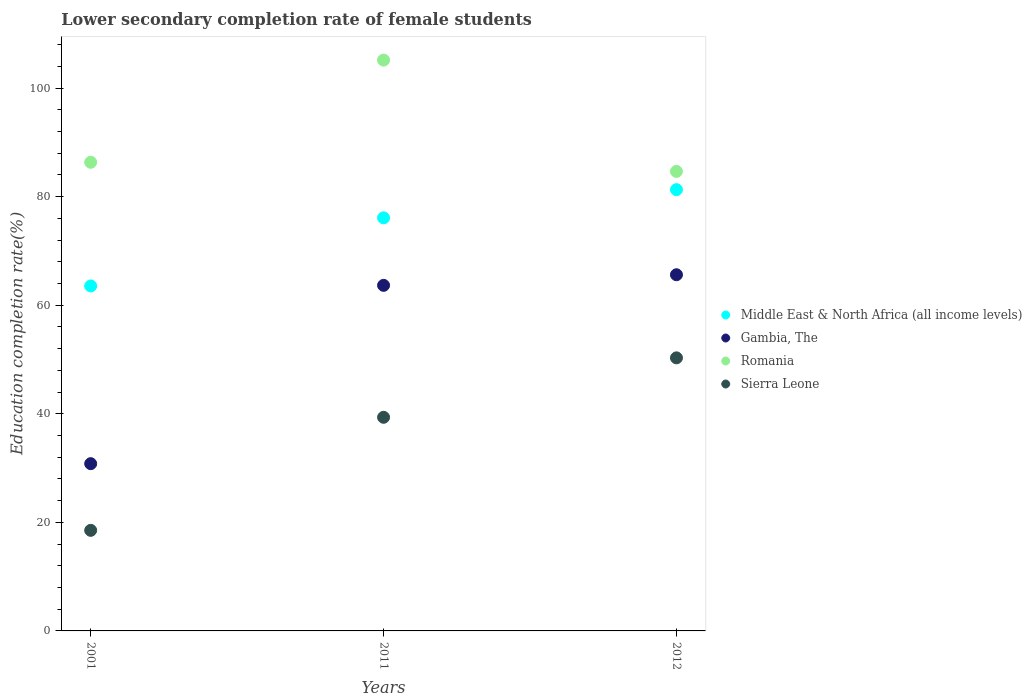Is the number of dotlines equal to the number of legend labels?
Ensure brevity in your answer.  Yes. What is the lower secondary completion rate of female students in Romania in 2012?
Provide a short and direct response. 84.65. Across all years, what is the maximum lower secondary completion rate of female students in Romania?
Give a very brief answer. 105.16. Across all years, what is the minimum lower secondary completion rate of female students in Romania?
Give a very brief answer. 84.65. In which year was the lower secondary completion rate of female students in Romania minimum?
Provide a short and direct response. 2012. What is the total lower secondary completion rate of female students in Romania in the graph?
Your answer should be compact. 276.15. What is the difference between the lower secondary completion rate of female students in Middle East & North Africa (all income levels) in 2011 and that in 2012?
Provide a short and direct response. -5.19. What is the difference between the lower secondary completion rate of female students in Middle East & North Africa (all income levels) in 2001 and the lower secondary completion rate of female students in Sierra Leone in 2012?
Keep it short and to the point. 13.24. What is the average lower secondary completion rate of female students in Romania per year?
Offer a terse response. 92.05. In the year 2012, what is the difference between the lower secondary completion rate of female students in Romania and lower secondary completion rate of female students in Middle East & North Africa (all income levels)?
Provide a succinct answer. 3.37. What is the ratio of the lower secondary completion rate of female students in Middle East & North Africa (all income levels) in 2001 to that in 2011?
Offer a very short reply. 0.84. Is the lower secondary completion rate of female students in Romania in 2001 less than that in 2012?
Make the answer very short. No. Is the difference between the lower secondary completion rate of female students in Romania in 2001 and 2011 greater than the difference between the lower secondary completion rate of female students in Middle East & North Africa (all income levels) in 2001 and 2011?
Make the answer very short. No. What is the difference between the highest and the second highest lower secondary completion rate of female students in Middle East & North Africa (all income levels)?
Give a very brief answer. 5.19. What is the difference between the highest and the lowest lower secondary completion rate of female students in Romania?
Give a very brief answer. 20.51. Is the sum of the lower secondary completion rate of female students in Gambia, The in 2011 and 2012 greater than the maximum lower secondary completion rate of female students in Romania across all years?
Your response must be concise. Yes. Is it the case that in every year, the sum of the lower secondary completion rate of female students in Gambia, The and lower secondary completion rate of female students in Romania  is greater than the sum of lower secondary completion rate of female students in Sierra Leone and lower secondary completion rate of female students in Middle East & North Africa (all income levels)?
Keep it short and to the point. No. Is the lower secondary completion rate of female students in Sierra Leone strictly greater than the lower secondary completion rate of female students in Middle East & North Africa (all income levels) over the years?
Your answer should be compact. No. How many years are there in the graph?
Make the answer very short. 3. What is the difference between two consecutive major ticks on the Y-axis?
Provide a succinct answer. 20. Does the graph contain any zero values?
Provide a short and direct response. No. What is the title of the graph?
Offer a terse response. Lower secondary completion rate of female students. What is the label or title of the X-axis?
Ensure brevity in your answer.  Years. What is the label or title of the Y-axis?
Ensure brevity in your answer.  Education completion rate(%). What is the Education completion rate(%) in Middle East & North Africa (all income levels) in 2001?
Make the answer very short. 63.55. What is the Education completion rate(%) in Gambia, The in 2001?
Provide a succinct answer. 30.81. What is the Education completion rate(%) of Romania in 2001?
Your response must be concise. 86.33. What is the Education completion rate(%) in Sierra Leone in 2001?
Make the answer very short. 18.53. What is the Education completion rate(%) in Middle East & North Africa (all income levels) in 2011?
Provide a succinct answer. 76.1. What is the Education completion rate(%) in Gambia, The in 2011?
Keep it short and to the point. 63.66. What is the Education completion rate(%) of Romania in 2011?
Provide a succinct answer. 105.16. What is the Education completion rate(%) of Sierra Leone in 2011?
Offer a very short reply. 39.35. What is the Education completion rate(%) of Middle East & North Africa (all income levels) in 2012?
Your answer should be compact. 81.29. What is the Education completion rate(%) of Gambia, The in 2012?
Offer a very short reply. 65.62. What is the Education completion rate(%) in Romania in 2012?
Provide a short and direct response. 84.65. What is the Education completion rate(%) of Sierra Leone in 2012?
Offer a very short reply. 50.3. Across all years, what is the maximum Education completion rate(%) of Middle East & North Africa (all income levels)?
Your answer should be compact. 81.29. Across all years, what is the maximum Education completion rate(%) of Gambia, The?
Provide a succinct answer. 65.62. Across all years, what is the maximum Education completion rate(%) in Romania?
Offer a very short reply. 105.16. Across all years, what is the maximum Education completion rate(%) in Sierra Leone?
Your response must be concise. 50.3. Across all years, what is the minimum Education completion rate(%) in Middle East & North Africa (all income levels)?
Ensure brevity in your answer.  63.55. Across all years, what is the minimum Education completion rate(%) in Gambia, The?
Make the answer very short. 30.81. Across all years, what is the minimum Education completion rate(%) in Romania?
Offer a very short reply. 84.65. Across all years, what is the minimum Education completion rate(%) of Sierra Leone?
Make the answer very short. 18.53. What is the total Education completion rate(%) in Middle East & North Africa (all income levels) in the graph?
Your answer should be very brief. 220.94. What is the total Education completion rate(%) in Gambia, The in the graph?
Ensure brevity in your answer.  160.09. What is the total Education completion rate(%) in Romania in the graph?
Give a very brief answer. 276.15. What is the total Education completion rate(%) in Sierra Leone in the graph?
Your response must be concise. 108.19. What is the difference between the Education completion rate(%) of Middle East & North Africa (all income levels) in 2001 and that in 2011?
Ensure brevity in your answer.  -12.55. What is the difference between the Education completion rate(%) of Gambia, The in 2001 and that in 2011?
Offer a terse response. -32.85. What is the difference between the Education completion rate(%) of Romania in 2001 and that in 2011?
Offer a very short reply. -18.83. What is the difference between the Education completion rate(%) in Sierra Leone in 2001 and that in 2011?
Your response must be concise. -20.83. What is the difference between the Education completion rate(%) of Middle East & North Africa (all income levels) in 2001 and that in 2012?
Your answer should be very brief. -17.74. What is the difference between the Education completion rate(%) of Gambia, The in 2001 and that in 2012?
Your answer should be compact. -34.81. What is the difference between the Education completion rate(%) in Romania in 2001 and that in 2012?
Your response must be concise. 1.68. What is the difference between the Education completion rate(%) of Sierra Leone in 2001 and that in 2012?
Make the answer very short. -31.78. What is the difference between the Education completion rate(%) in Middle East & North Africa (all income levels) in 2011 and that in 2012?
Offer a very short reply. -5.19. What is the difference between the Education completion rate(%) in Gambia, The in 2011 and that in 2012?
Provide a succinct answer. -1.95. What is the difference between the Education completion rate(%) in Romania in 2011 and that in 2012?
Provide a short and direct response. 20.51. What is the difference between the Education completion rate(%) of Sierra Leone in 2011 and that in 2012?
Make the answer very short. -10.95. What is the difference between the Education completion rate(%) of Middle East & North Africa (all income levels) in 2001 and the Education completion rate(%) of Gambia, The in 2011?
Your answer should be compact. -0.11. What is the difference between the Education completion rate(%) in Middle East & North Africa (all income levels) in 2001 and the Education completion rate(%) in Romania in 2011?
Provide a short and direct response. -41.61. What is the difference between the Education completion rate(%) in Middle East & North Africa (all income levels) in 2001 and the Education completion rate(%) in Sierra Leone in 2011?
Provide a short and direct response. 24.19. What is the difference between the Education completion rate(%) in Gambia, The in 2001 and the Education completion rate(%) in Romania in 2011?
Provide a short and direct response. -74.35. What is the difference between the Education completion rate(%) in Gambia, The in 2001 and the Education completion rate(%) in Sierra Leone in 2011?
Provide a short and direct response. -8.54. What is the difference between the Education completion rate(%) of Romania in 2001 and the Education completion rate(%) of Sierra Leone in 2011?
Your response must be concise. 46.98. What is the difference between the Education completion rate(%) in Middle East & North Africa (all income levels) in 2001 and the Education completion rate(%) in Gambia, The in 2012?
Give a very brief answer. -2.07. What is the difference between the Education completion rate(%) in Middle East & North Africa (all income levels) in 2001 and the Education completion rate(%) in Romania in 2012?
Offer a terse response. -21.11. What is the difference between the Education completion rate(%) in Middle East & North Africa (all income levels) in 2001 and the Education completion rate(%) in Sierra Leone in 2012?
Give a very brief answer. 13.24. What is the difference between the Education completion rate(%) in Gambia, The in 2001 and the Education completion rate(%) in Romania in 2012?
Your answer should be compact. -53.84. What is the difference between the Education completion rate(%) of Gambia, The in 2001 and the Education completion rate(%) of Sierra Leone in 2012?
Give a very brief answer. -19.49. What is the difference between the Education completion rate(%) of Romania in 2001 and the Education completion rate(%) of Sierra Leone in 2012?
Provide a short and direct response. 36.03. What is the difference between the Education completion rate(%) in Middle East & North Africa (all income levels) in 2011 and the Education completion rate(%) in Gambia, The in 2012?
Give a very brief answer. 10.48. What is the difference between the Education completion rate(%) of Middle East & North Africa (all income levels) in 2011 and the Education completion rate(%) of Romania in 2012?
Offer a terse response. -8.55. What is the difference between the Education completion rate(%) in Middle East & North Africa (all income levels) in 2011 and the Education completion rate(%) in Sierra Leone in 2012?
Make the answer very short. 25.8. What is the difference between the Education completion rate(%) of Gambia, The in 2011 and the Education completion rate(%) of Romania in 2012?
Provide a succinct answer. -20.99. What is the difference between the Education completion rate(%) in Gambia, The in 2011 and the Education completion rate(%) in Sierra Leone in 2012?
Your response must be concise. 13.36. What is the difference between the Education completion rate(%) of Romania in 2011 and the Education completion rate(%) of Sierra Leone in 2012?
Offer a very short reply. 54.86. What is the average Education completion rate(%) in Middle East & North Africa (all income levels) per year?
Give a very brief answer. 73.65. What is the average Education completion rate(%) in Gambia, The per year?
Your answer should be very brief. 53.36. What is the average Education completion rate(%) of Romania per year?
Ensure brevity in your answer.  92.05. What is the average Education completion rate(%) of Sierra Leone per year?
Your answer should be compact. 36.06. In the year 2001, what is the difference between the Education completion rate(%) in Middle East & North Africa (all income levels) and Education completion rate(%) in Gambia, The?
Provide a short and direct response. 32.74. In the year 2001, what is the difference between the Education completion rate(%) of Middle East & North Africa (all income levels) and Education completion rate(%) of Romania?
Your answer should be very brief. -22.79. In the year 2001, what is the difference between the Education completion rate(%) of Middle East & North Africa (all income levels) and Education completion rate(%) of Sierra Leone?
Your answer should be compact. 45.02. In the year 2001, what is the difference between the Education completion rate(%) of Gambia, The and Education completion rate(%) of Romania?
Give a very brief answer. -55.52. In the year 2001, what is the difference between the Education completion rate(%) in Gambia, The and Education completion rate(%) in Sierra Leone?
Offer a terse response. 12.28. In the year 2001, what is the difference between the Education completion rate(%) in Romania and Education completion rate(%) in Sierra Leone?
Provide a succinct answer. 67.81. In the year 2011, what is the difference between the Education completion rate(%) in Middle East & North Africa (all income levels) and Education completion rate(%) in Gambia, The?
Keep it short and to the point. 12.44. In the year 2011, what is the difference between the Education completion rate(%) in Middle East & North Africa (all income levels) and Education completion rate(%) in Romania?
Your response must be concise. -29.06. In the year 2011, what is the difference between the Education completion rate(%) of Middle East & North Africa (all income levels) and Education completion rate(%) of Sierra Leone?
Provide a short and direct response. 36.75. In the year 2011, what is the difference between the Education completion rate(%) of Gambia, The and Education completion rate(%) of Romania?
Ensure brevity in your answer.  -41.5. In the year 2011, what is the difference between the Education completion rate(%) in Gambia, The and Education completion rate(%) in Sierra Leone?
Offer a very short reply. 24.31. In the year 2011, what is the difference between the Education completion rate(%) of Romania and Education completion rate(%) of Sierra Leone?
Your answer should be compact. 65.81. In the year 2012, what is the difference between the Education completion rate(%) in Middle East & North Africa (all income levels) and Education completion rate(%) in Gambia, The?
Make the answer very short. 15.67. In the year 2012, what is the difference between the Education completion rate(%) of Middle East & North Africa (all income levels) and Education completion rate(%) of Romania?
Your response must be concise. -3.37. In the year 2012, what is the difference between the Education completion rate(%) of Middle East & North Africa (all income levels) and Education completion rate(%) of Sierra Leone?
Your answer should be compact. 30.98. In the year 2012, what is the difference between the Education completion rate(%) in Gambia, The and Education completion rate(%) in Romania?
Provide a succinct answer. -19.04. In the year 2012, what is the difference between the Education completion rate(%) of Gambia, The and Education completion rate(%) of Sierra Leone?
Ensure brevity in your answer.  15.31. In the year 2012, what is the difference between the Education completion rate(%) of Romania and Education completion rate(%) of Sierra Leone?
Provide a short and direct response. 34.35. What is the ratio of the Education completion rate(%) in Middle East & North Africa (all income levels) in 2001 to that in 2011?
Give a very brief answer. 0.84. What is the ratio of the Education completion rate(%) of Gambia, The in 2001 to that in 2011?
Make the answer very short. 0.48. What is the ratio of the Education completion rate(%) in Romania in 2001 to that in 2011?
Your response must be concise. 0.82. What is the ratio of the Education completion rate(%) of Sierra Leone in 2001 to that in 2011?
Your answer should be compact. 0.47. What is the ratio of the Education completion rate(%) in Middle East & North Africa (all income levels) in 2001 to that in 2012?
Provide a short and direct response. 0.78. What is the ratio of the Education completion rate(%) of Gambia, The in 2001 to that in 2012?
Your answer should be compact. 0.47. What is the ratio of the Education completion rate(%) in Romania in 2001 to that in 2012?
Give a very brief answer. 1.02. What is the ratio of the Education completion rate(%) in Sierra Leone in 2001 to that in 2012?
Provide a succinct answer. 0.37. What is the ratio of the Education completion rate(%) in Middle East & North Africa (all income levels) in 2011 to that in 2012?
Provide a short and direct response. 0.94. What is the ratio of the Education completion rate(%) of Gambia, The in 2011 to that in 2012?
Offer a terse response. 0.97. What is the ratio of the Education completion rate(%) of Romania in 2011 to that in 2012?
Your response must be concise. 1.24. What is the ratio of the Education completion rate(%) of Sierra Leone in 2011 to that in 2012?
Your response must be concise. 0.78. What is the difference between the highest and the second highest Education completion rate(%) in Middle East & North Africa (all income levels)?
Make the answer very short. 5.19. What is the difference between the highest and the second highest Education completion rate(%) in Gambia, The?
Keep it short and to the point. 1.95. What is the difference between the highest and the second highest Education completion rate(%) in Romania?
Provide a succinct answer. 18.83. What is the difference between the highest and the second highest Education completion rate(%) of Sierra Leone?
Offer a terse response. 10.95. What is the difference between the highest and the lowest Education completion rate(%) in Middle East & North Africa (all income levels)?
Provide a short and direct response. 17.74. What is the difference between the highest and the lowest Education completion rate(%) of Gambia, The?
Offer a very short reply. 34.81. What is the difference between the highest and the lowest Education completion rate(%) in Romania?
Give a very brief answer. 20.51. What is the difference between the highest and the lowest Education completion rate(%) of Sierra Leone?
Provide a short and direct response. 31.78. 